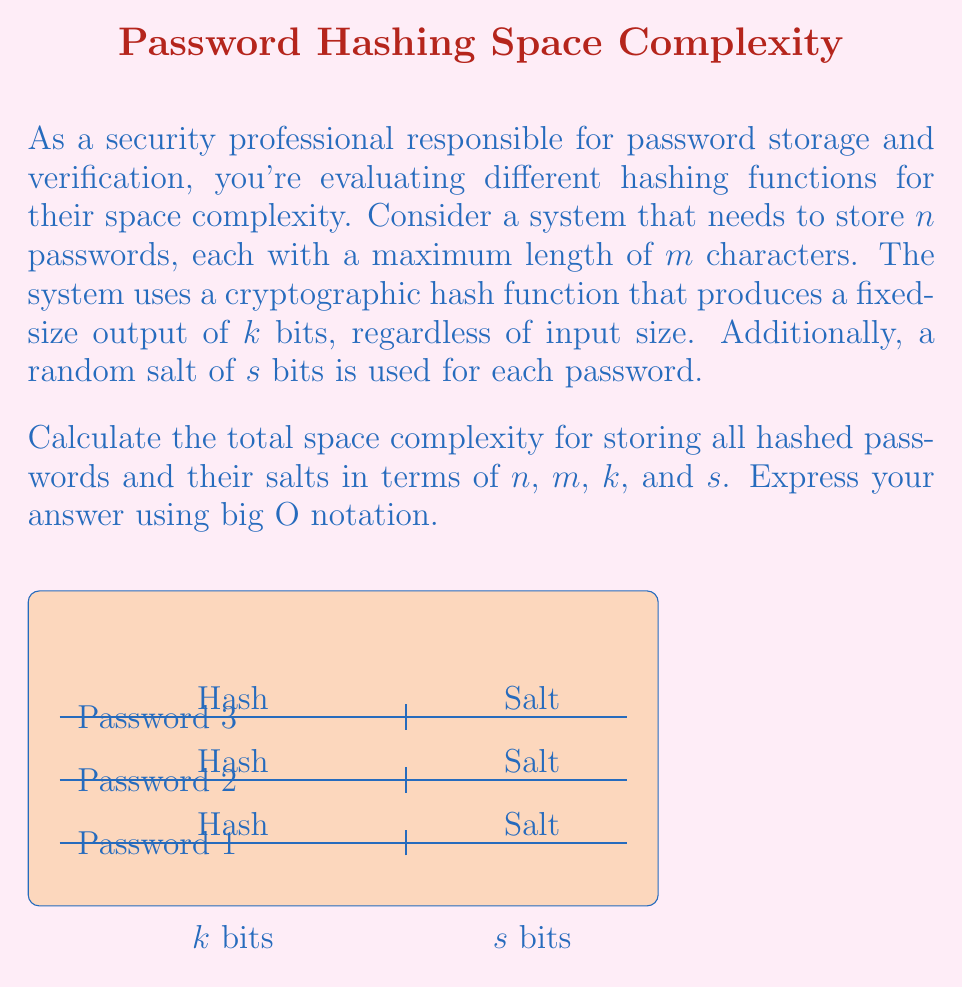Give your solution to this math problem. To calculate the space complexity, we need to consider the following components:

1. Hashed passwords:
   - Each hashed password occupies $k$ bits
   - There are $n$ passwords
   - Total space for hashes: $n \cdot k$ bits

2. Salt values:
   - Each salt occupies $s$ bits
   - There are $n$ passwords, each with its own salt
   - Total space for salts: $n \cdot s$ bits

3. The input password length $m$ does not affect the space complexity because the hash function produces a fixed-size output regardless of input size.

4. Total space required:
   $$ \text{Total Space} = n \cdot k + n \cdot s = n(k + s) \text{ bits} $$

5. Converting to big O notation:
   - We consider $n$ as the primary variable, as it represents the number of passwords in the system.
   - $k$ and $s$ are constants determined by the chosen hash function and salt size.
   - The expression $n(k + s)$ is linear in terms of $n$.

Therefore, the space complexity can be expressed as $O(n)$.

It's worth noting that while $k$ and $s$ are constants in big O notation, they can significantly impact the actual space usage. In practice, typical values might be:
- $k = 256$ bits (for SHA-256)
- $s = 128$ bits (for a 128-bit salt)

This would result in 384 bits (48 bytes) per password entry, which can add up quickly for large user databases.
Answer: $O(n)$ 